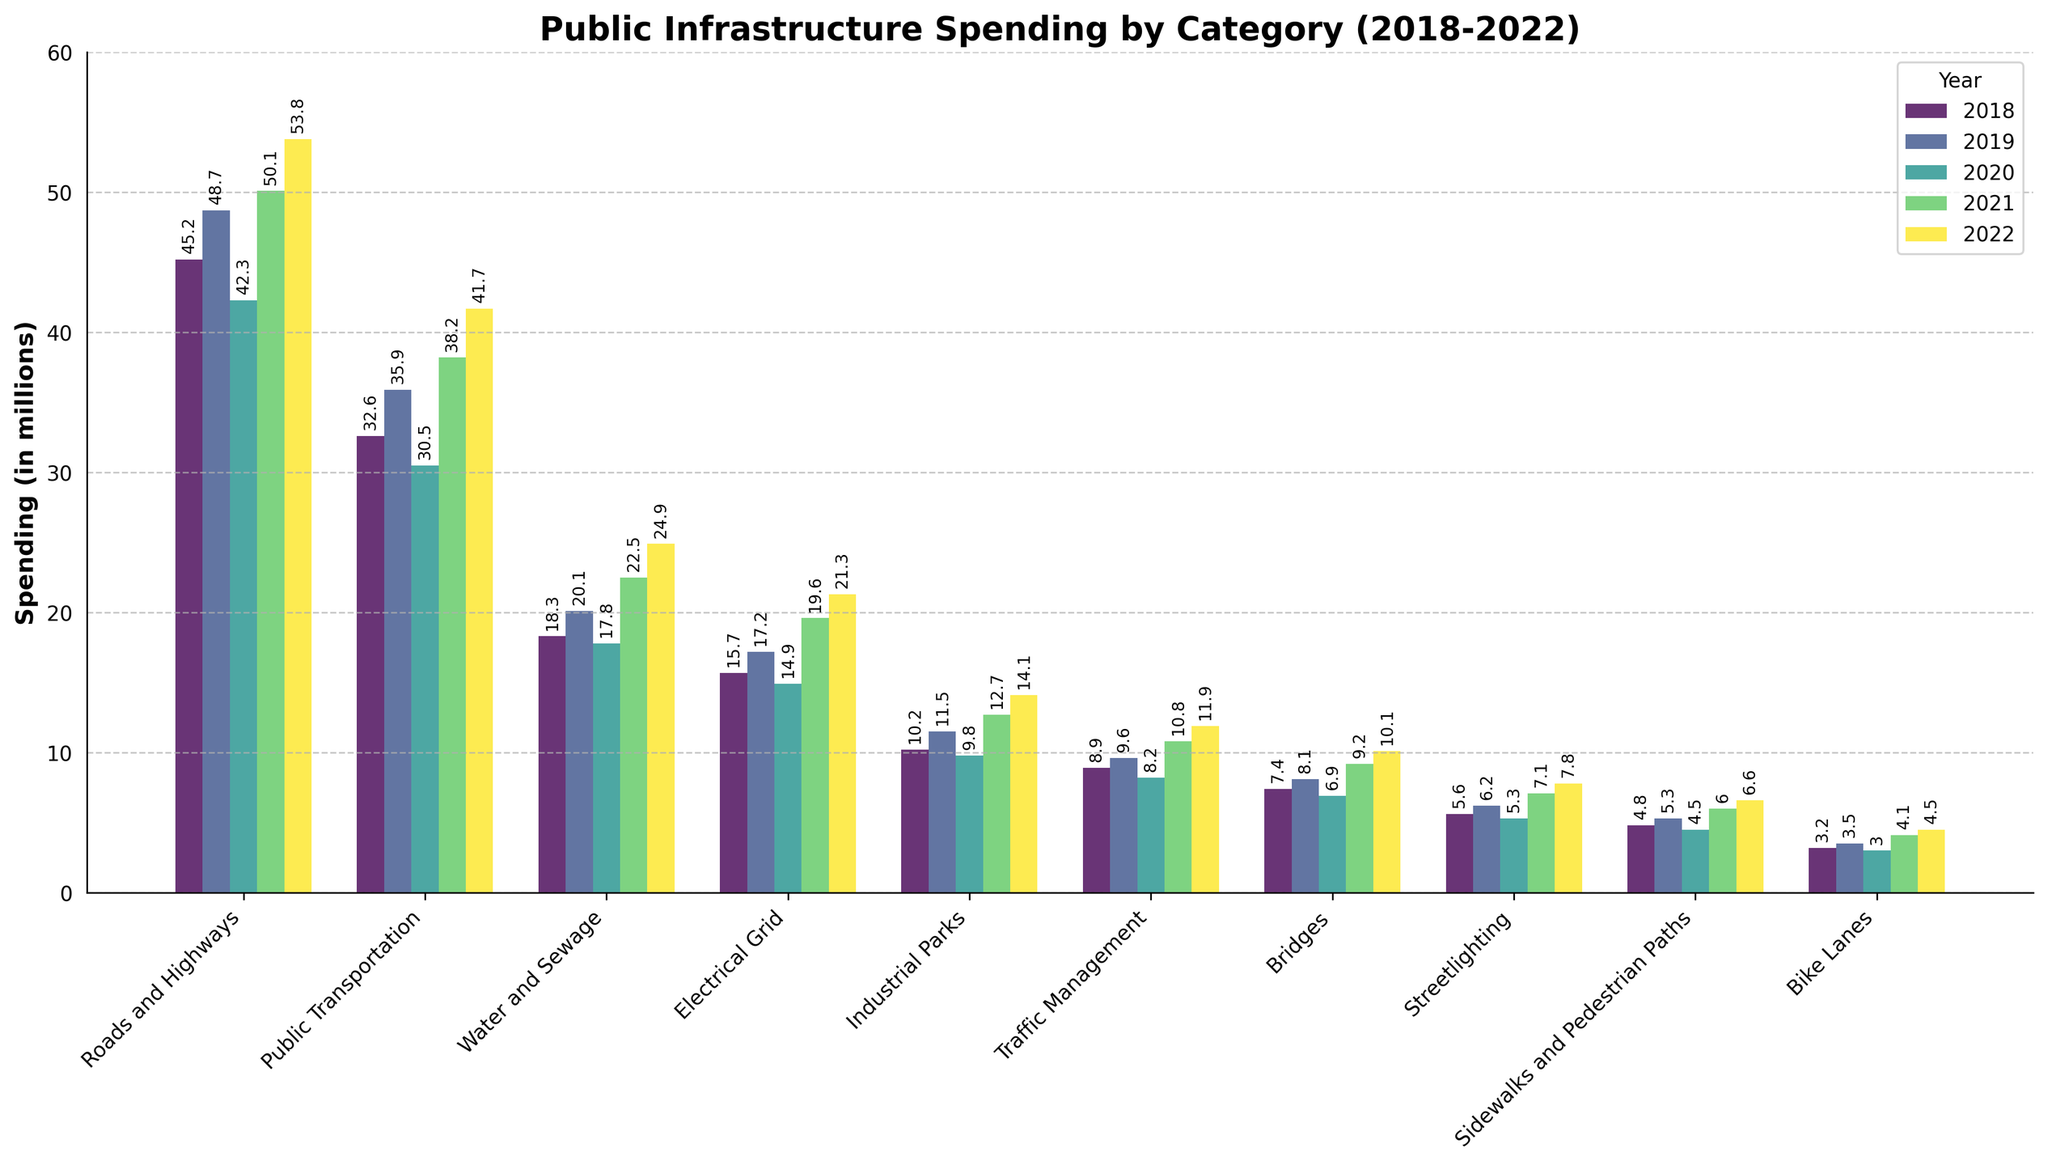Which category had the highest spending in 2022? Look for the tallest bar associated with the year 2022. The tallest bar is for "Roads and Highways."
Answer: Roads and Highways By how much did spending on Public Transportation increase from 2018 to 2022? Refer to the height of bars representing Public Transportation for 2018 and 2022. Subtract the 2018 value (32.6) from the 2022 value (41.7): 41.7 - 32.6 = 9.1 million.
Answer: 9.1 million Which category had the smallest increase in spending from 2018 to 2022, and by how much? Calculate the difference in spending from 2018 to 2022 for each category and identify the smallest value. For Bike Lanes, it’s 4.5 - 3.2 = 1.3 million, which is the smallest increase.
Answer: Bike Lanes, 1.3 million In which year was the spending on Electrical Grid highest? Look for the tallest bar associated with Electrical Grid across all years. The highest bar is in 2022.
Answer: 2022 How does the spending trend on Water and Sewage compare to the trend on Traffic Management over the 5 years? Evaluate the bars for Water and Sewage and Traffic Management for each year from 2018 to 2022. Both categories show a generally increasing trend.
Answer: Both show an increasing trend What is the total spending on Streetlighting across the 5 years? Sum the spending on Streetlighting for each year: 5.6 + 6.2 + 5.3 + 7.1 + 7.8 = 32.0 million.
Answer: 32.0 million Compare the spending in 2020 for Roads and Highways and Public Transportation. Which category had higher spending and by how much? Look at the bar heights for Roads and Highways (42.3) and Public Transportation (30.5) in 2020. Subtract Public Transportation from Roads and Highways: 42.3 - 30.5 = 11.8 million.
Answer: Roads and Highways, 11.8 million Which year had the lowest total public infrastructure spending across all categories? Sum the spending for each year and determine the year with the smallest total. For 2018: 45.2 + 32.6 + 18.3 + 15.7 + 10.2 + 8.9 + 7.4 + 5.6 + 4.8 + 3.2 = 151.9; 2019: 167.8; 2020: 138.2; 2021: 179.1; 2022: 196.6. The smallest total is in 2020.
Answer: 2020 